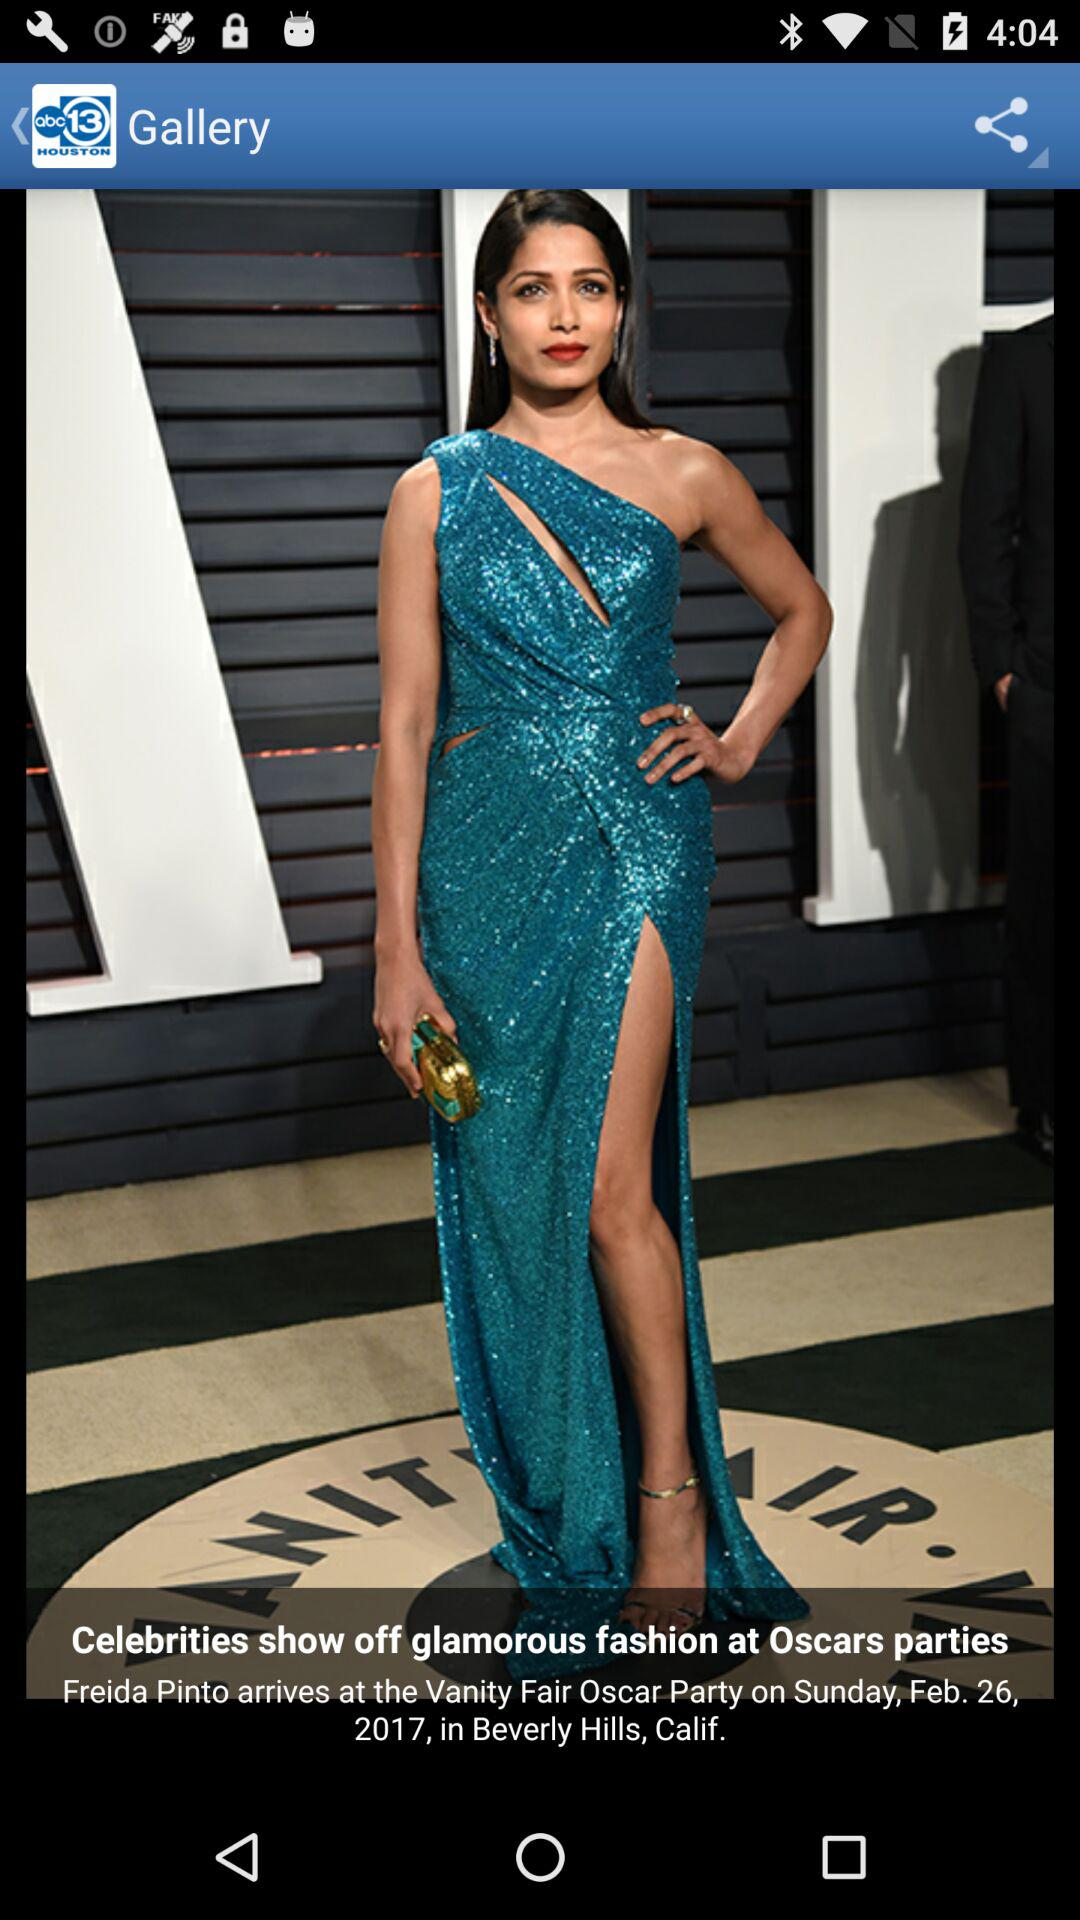What is the name of the application? The name of the application is "ABC13 Houston News & Weather". 